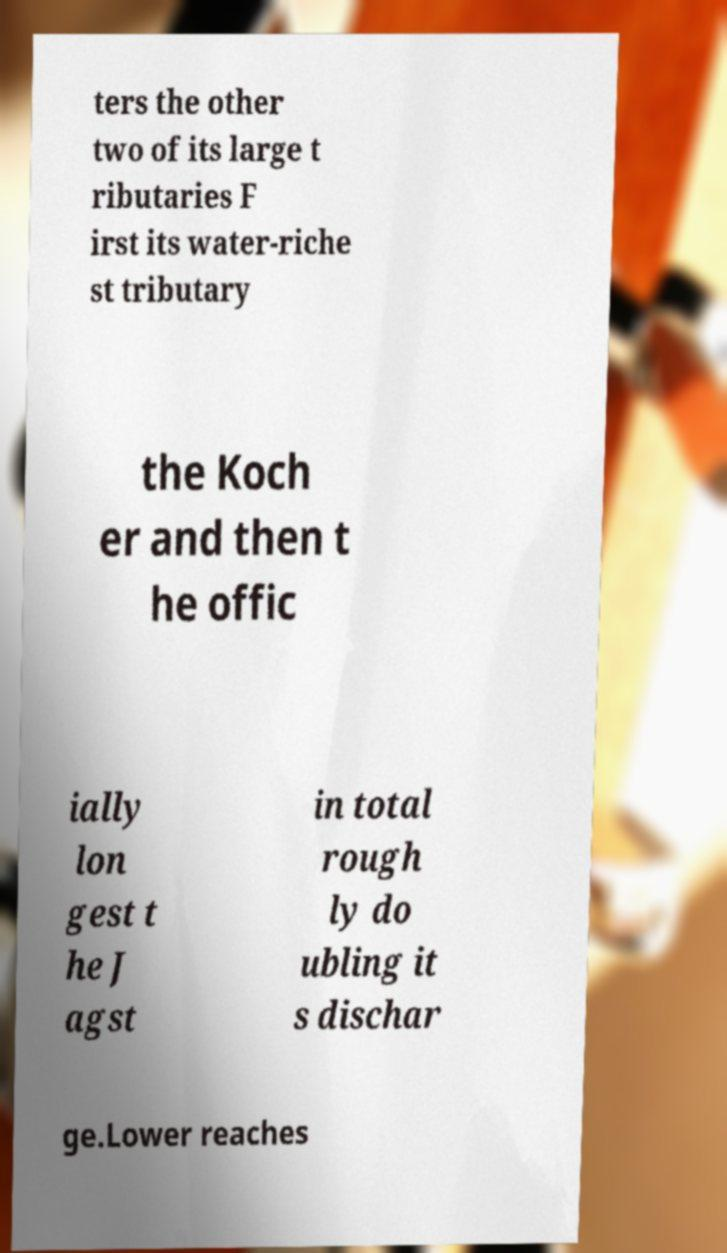Please identify and transcribe the text found in this image. ters the other two of its large t ributaries F irst its water-riche st tributary the Koch er and then t he offic ially lon gest t he J agst in total rough ly do ubling it s dischar ge.Lower reaches 